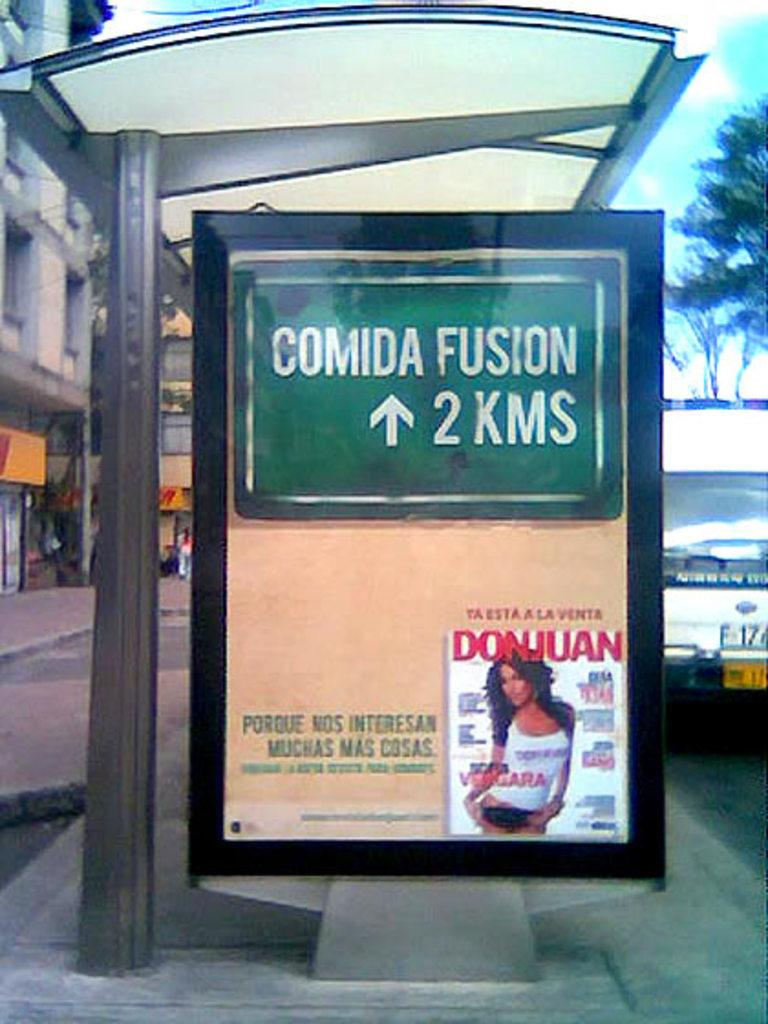<image>
Offer a succinct explanation of the picture presented. A bus shelter with an ad for a magazine called DonJuan at the bottom. 